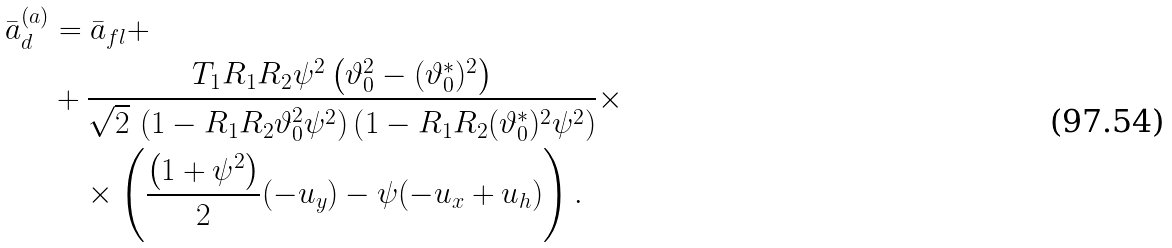Convert formula to latex. <formula><loc_0><loc_0><loc_500><loc_500>\bar { a } _ { d } ^ { ( a ) } & = \bar { a } _ { f l } + \\ & + \frac { T _ { 1 } R _ { 1 } R _ { 2 } \psi ^ { 2 } \left ( \vartheta _ { 0 } ^ { 2 } - ( \vartheta _ { 0 } ^ { * } ) ^ { 2 } \right ) } { \sqrt { 2 } \, \left ( 1 - R _ { 1 } R _ { 2 } \vartheta _ { 0 } ^ { 2 } \psi ^ { 2 } \right ) \left ( 1 - R _ { 1 } R _ { 2 } ( \vartheta _ { 0 } ^ { * } ) ^ { 2 } \psi ^ { 2 } \right ) } \times \\ & \quad \times \left ( \frac { \left ( 1 + \psi ^ { 2 } \right ) } { 2 } ( - u _ { y } ) - \psi ( - u _ { x } + u _ { h } ) \right ) .</formula> 